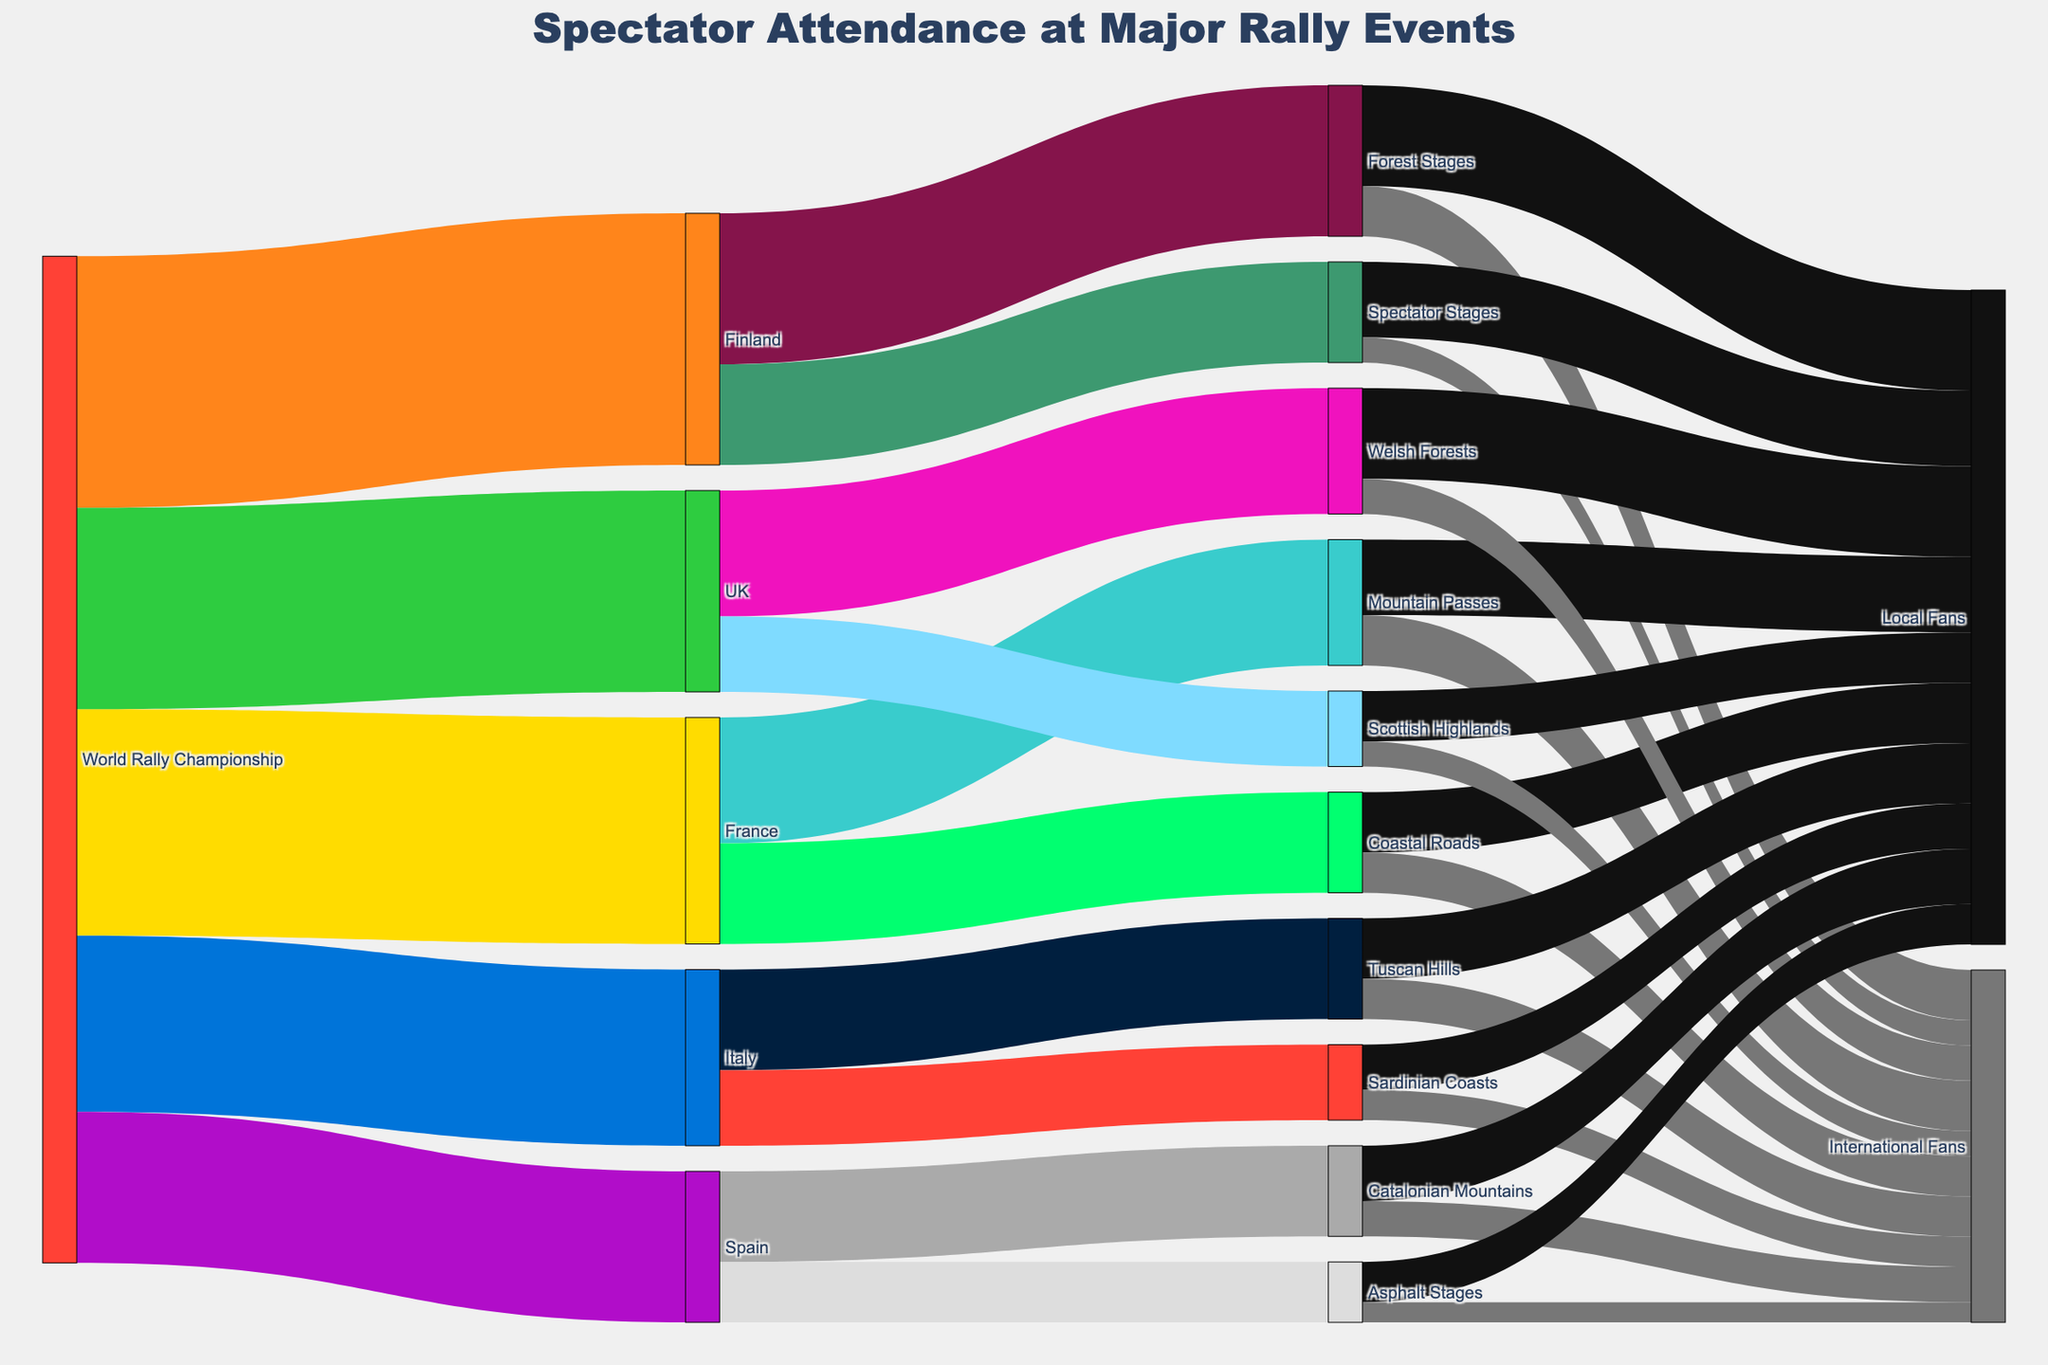What's the title of the figure? The title is usually displayed at the top of the diagram.
Answer: Spectator Attendance at Major Rally Events How many countries are detailed for spectator attendance in the World Rally Championship? The Sankey diagram shows branches from the "World Rally Championship" to various countries. Count the distinct country labels.
Answer: Five countries (Finland, France, UK, Italy, Spain) Which viewing location in Finland has the highest number of spectators? Trace the flow from "Finland" to its viewing locations. Compare the values.
Answer: Forest Stages How many international fans attended Spectator Stages in Finland? Follow the flow from "Spectator Stages" to "International Fans" in the section for Finland.
Answer: 5000 What is the total number of local fans attending UK viewing locations? Sum the values of local fans attending Welsh Forests and Scottish Highlands.
Answer: 18000 + 10000 = 28000 Which country has more fans at Coastal Roads, and by how much? Find the values of Coastal Roads linked with different countries and compare. In this case, only France has Coastal Roads.
Answer: France, 20000 What's the difference in spectator attendance between Forest Stages and Spectator Stages in Finland? Subtract the number of spectators attending Spectator Stages from those attending Forest Stages in Finland.
Answer: 30000 - 20000 = 10000 How many local fans in total attended viewing locations in Spain? Add the numbers of local fans at Catalonian Mountains and Asphalt Stages.
Answer: 11000 + 8000 = 19000 Which stage type in Italy has fewer international fans, and what is the difference in numbers? Compare the number of international fans at Tuscan Hills and Sardinian Coasts.
Answer: Sardinian Coasts has fewer, by 2000 (8000 - 6000) What proportion of fans at Mountain Passes in France are local fans? Divide the number of local fans by the total number of fans at Mountain Passes, then multiply by 100 for percentage.
Answer: (15000 / 25000) * 100 = 60% 